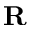<formula> <loc_0><loc_0><loc_500><loc_500>R</formula> 